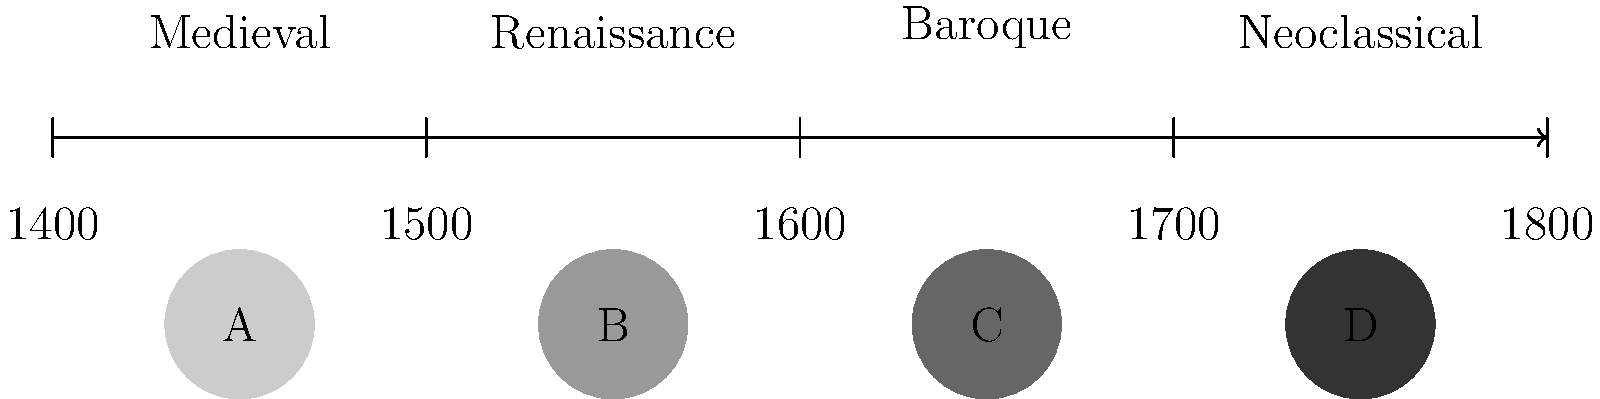Based on the timeline and sample portraits provided, which lettered portrait is most likely to represent the chiaroscuro technique popularized during the Baroque period? To answer this question, we need to consider the evolution of portraiture techniques across the centuries depicted in the timeline:

1. Medieval period (c. 1400): Characterized by flat, stylized representations with little depth or realism.

2. Renaissance (c. 1500): Introduced linear perspective and more naturalistic depictions, but still with relatively even lighting.

3. Baroque (c. 1600): Popularized the chiaroscuro technique, which uses strong contrasts between light and dark to create depth and drama.

4. Neoclassical (c. 1700): Returned to a more balanced, restrained style with clearer outlines and less dramatic lighting.

Looking at the sample portraits:

A: Lightest shading, likely representing the flat style of Medieval art.
B: Slightly darker, possibly representing Renaissance with some modeling.
C: Significantly darker, suggesting strong contrast typical of Baroque chiaroscuro.
D: Darkest overall, but not necessarily indicative of chiaroscuro; could represent later styles.

The chiaroscuro technique is most closely associated with the Baroque period, which emphasizes dramatic contrasts between light and dark. Portrait C, with its pronounced shading, best represents this technique among the given samples.
Answer: C 